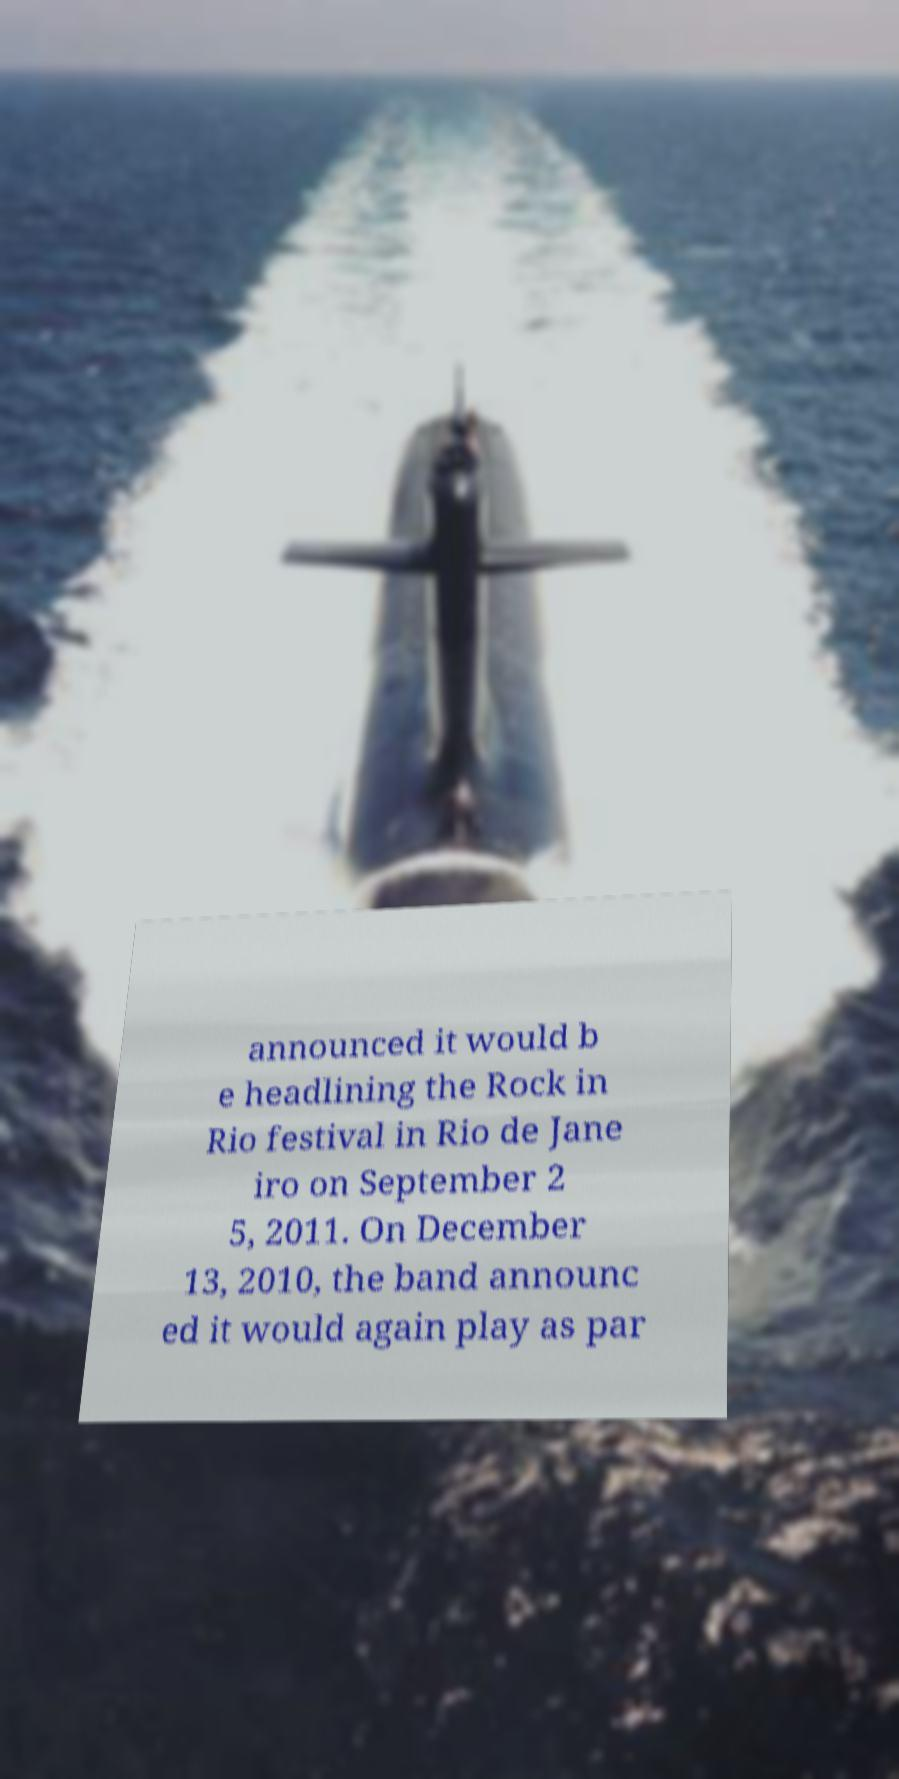Please read and relay the text visible in this image. What does it say? announced it would b e headlining the Rock in Rio festival in Rio de Jane iro on September 2 5, 2011. On December 13, 2010, the band announc ed it would again play as par 